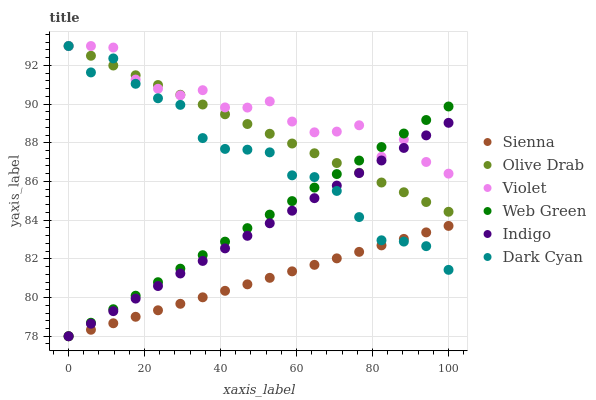Does Sienna have the minimum area under the curve?
Answer yes or no. Yes. Does Violet have the maximum area under the curve?
Answer yes or no. Yes. Does Web Green have the minimum area under the curve?
Answer yes or no. No. Does Web Green have the maximum area under the curve?
Answer yes or no. No. Is Olive Drab the smoothest?
Answer yes or no. Yes. Is Violet the roughest?
Answer yes or no. Yes. Is Web Green the smoothest?
Answer yes or no. No. Is Web Green the roughest?
Answer yes or no. No. Does Indigo have the lowest value?
Answer yes or no. Yes. Does Violet have the lowest value?
Answer yes or no. No. Does Olive Drab have the highest value?
Answer yes or no. Yes. Does Web Green have the highest value?
Answer yes or no. No. Is Sienna less than Olive Drab?
Answer yes or no. Yes. Is Violet greater than Sienna?
Answer yes or no. Yes. Does Olive Drab intersect Violet?
Answer yes or no. Yes. Is Olive Drab less than Violet?
Answer yes or no. No. Is Olive Drab greater than Violet?
Answer yes or no. No. Does Sienna intersect Olive Drab?
Answer yes or no. No. 